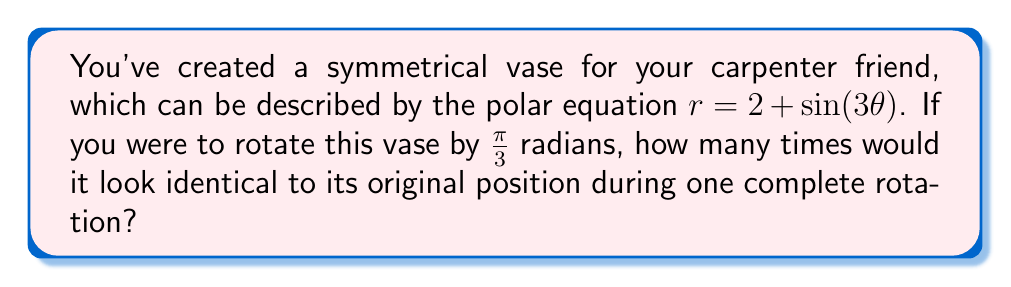Show me your answer to this math problem. Let's approach this step-by-step:

1) The symmetry of a polar equation can be determined by the coefficient of $\theta$ inside the trigonometric function. In this case, we have $\sin(3\theta)$.

2) The coefficient 3 indicates that the shape has 3-fold rotational symmetry. This means the shape will repeat itself 3 times in a full rotation of $2\pi$ radians.

3) To find how many times the vase will look identical during one rotation, we need to consider:
   a) The inherent symmetry of the shape (3 times)
   b) The rotation applied to the vase ($\frac{\pi}{3}$ radians)

4) The rotation of $\frac{\pi}{3}$ radians is equivalent to $\frac{1}{6}$ of a full rotation ($\frac{\pi}{3} = \frac{2\pi}{6}$).

5) To find how many times the rotated vase will align with its original position, we need to find the least common multiple (LCM) of 3 (the symmetry) and 6 (the denominator of the rotation fraction).

6) $LCM(3,6) = 6$

Therefore, the vase will look identical to its original position 6 times during one complete rotation.
Answer: 6 times 